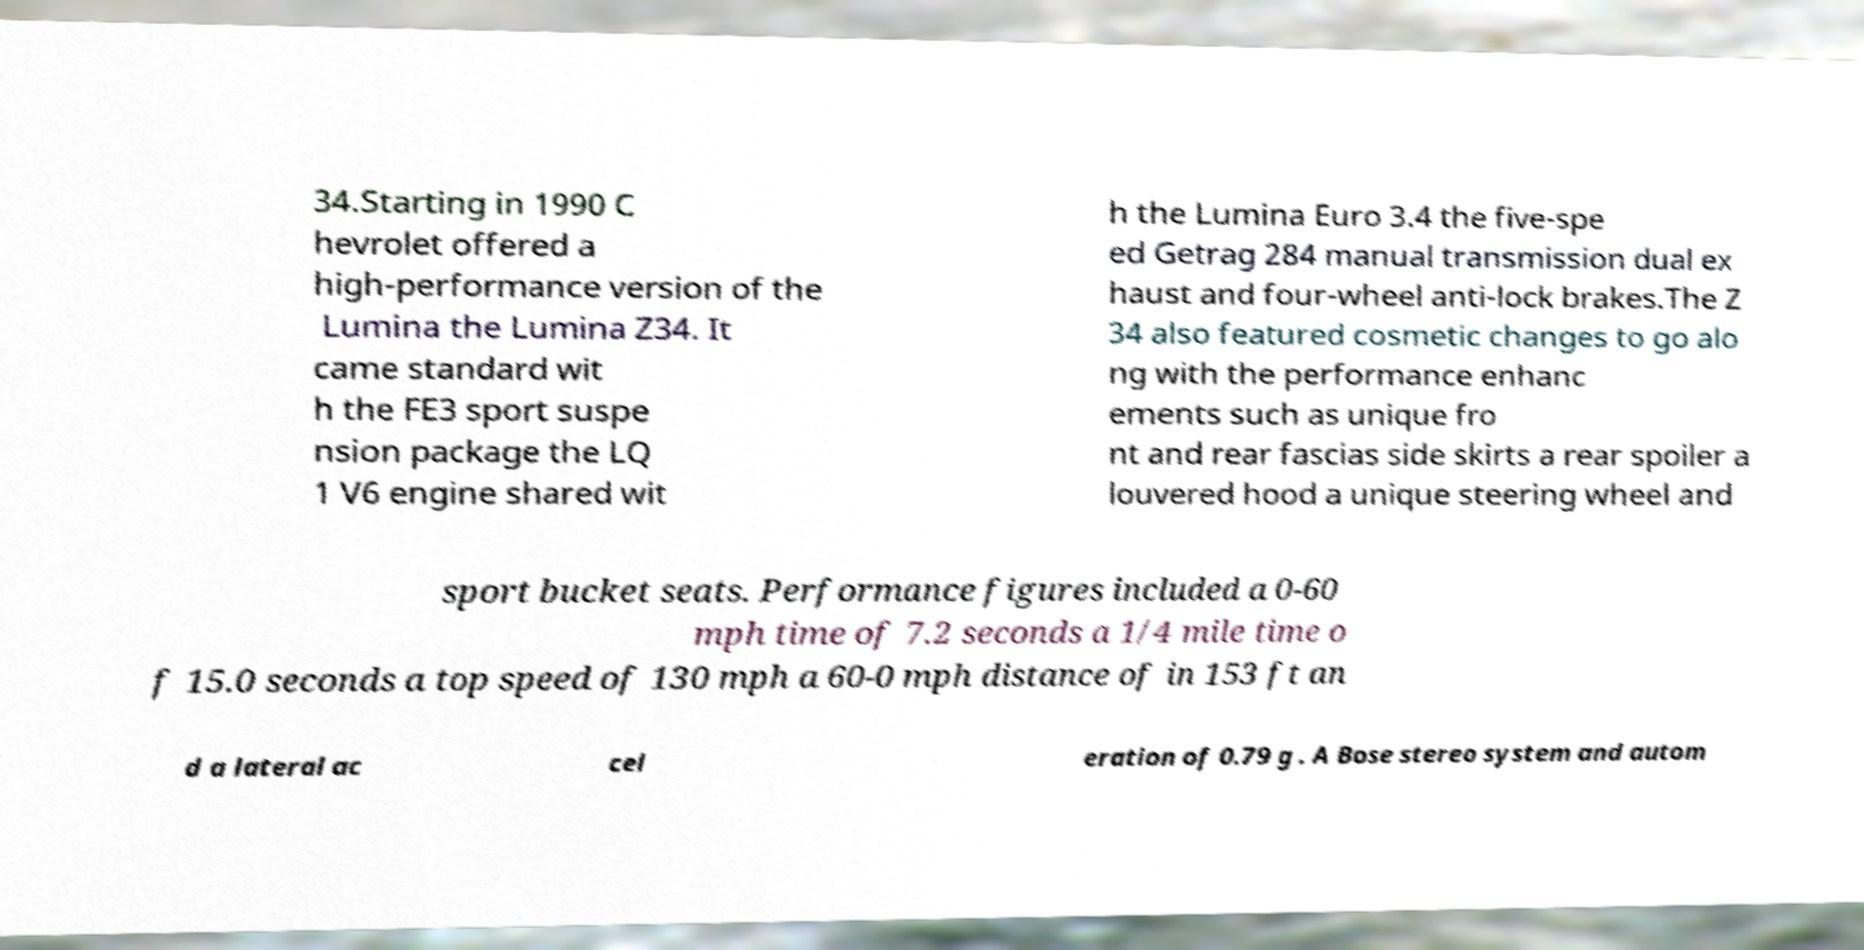What messages or text are displayed in this image? I need them in a readable, typed format. 34.Starting in 1990 C hevrolet offered a high-performance version of the Lumina the Lumina Z34. It came standard wit h the FE3 sport suspe nsion package the LQ 1 V6 engine shared wit h the Lumina Euro 3.4 the five-spe ed Getrag 284 manual transmission dual ex haust and four-wheel anti-lock brakes.The Z 34 also featured cosmetic changes to go alo ng with the performance enhanc ements such as unique fro nt and rear fascias side skirts a rear spoiler a louvered hood a unique steering wheel and sport bucket seats. Performance figures included a 0-60 mph time of 7.2 seconds a 1/4 mile time o f 15.0 seconds a top speed of 130 mph a 60-0 mph distance of in 153 ft an d a lateral ac cel eration of 0.79 g . A Bose stereo system and autom 